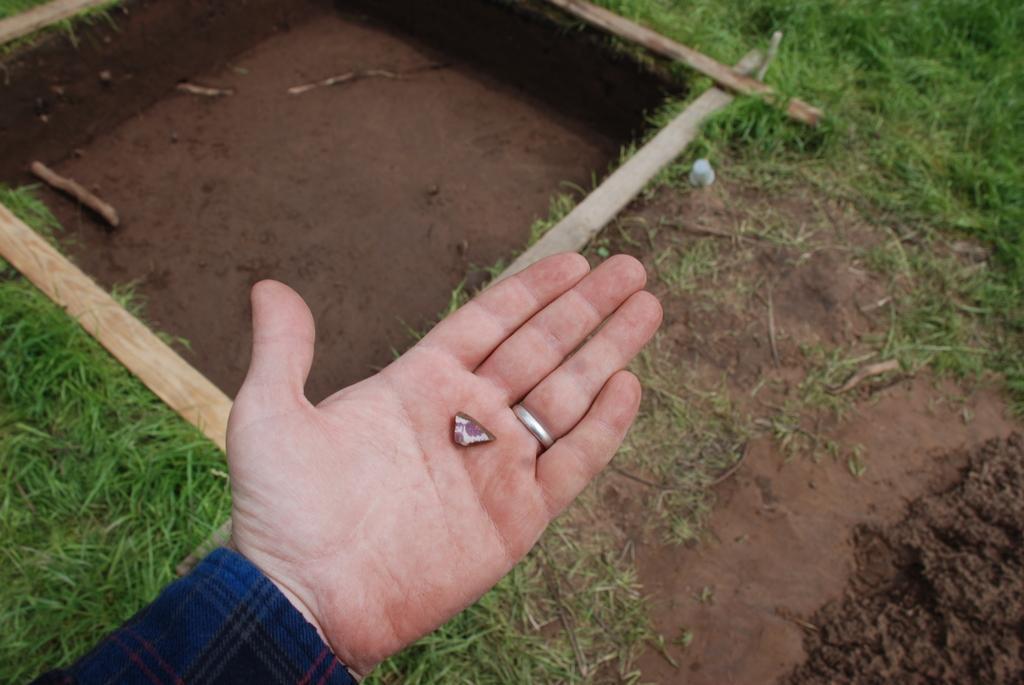Describe this image in one or two sentences. In this image there is a hand of the person in the front and on the ground there is grass. 